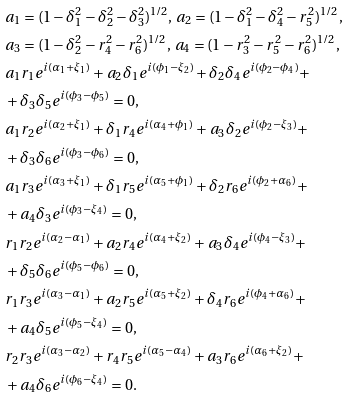<formula> <loc_0><loc_0><loc_500><loc_500>& a _ { 1 } = ( 1 - \delta ^ { 2 } _ { 1 } - \delta ^ { 2 } _ { 2 } - \delta ^ { 2 } _ { 3 } ) ^ { 1 / 2 } , \, a _ { 2 } = ( 1 - \delta ^ { 2 } _ { 1 } - \delta ^ { 2 } _ { 4 } - r ^ { 2 } _ { 5 } ) ^ { 1 / 2 } , \\ & a _ { 3 } = ( 1 - \delta ^ { 2 } _ { 2 } - r ^ { 2 } _ { 4 } - r ^ { 2 } _ { 6 } ) ^ { 1 / 2 } , \, a _ { 4 } = ( 1 - r ^ { 2 } _ { 3 } - r ^ { 2 } _ { 5 } - r ^ { 2 } _ { 6 } ) ^ { 1 / 2 } , \\ & a _ { 1 } r _ { 1 } e ^ { i ( \alpha _ { 1 } + \xi _ { 1 } ) } + a _ { 2 } \delta _ { 1 } e ^ { i ( \phi _ { 1 } - \xi _ { 2 } ) } + \delta _ { 2 } \delta _ { 4 } e ^ { i ( \phi _ { 2 } - \phi _ { 4 } ) } + \\ & + \delta _ { 3 } \delta _ { 5 } e ^ { i ( \phi _ { 3 } - \phi _ { 5 } ) } = 0 , \\ & a _ { 1 } r _ { 2 } e ^ { i ( \alpha _ { 2 } + \xi _ { 1 } ) } + \delta _ { 1 } r _ { 4 } e ^ { i ( \alpha _ { 4 } + \phi _ { 1 } ) } + a _ { 3 } \delta _ { 2 } e ^ { i ( \phi _ { 2 } - \xi _ { 3 } ) } + \\ & + \delta _ { 3 } \delta _ { 6 } e ^ { i ( \phi _ { 3 } - \phi _ { 6 } ) } = 0 , \\ & a _ { 1 } r _ { 3 } e ^ { i ( \alpha _ { 3 } + \xi _ { 1 } ) } + \delta _ { 1 } r _ { 5 } e ^ { i ( \alpha _ { 5 } + \phi _ { 1 } ) } + \delta _ { 2 } r _ { 6 } e ^ { i ( \phi _ { 2 } + \alpha _ { 6 } ) } + \\ & + a _ { 4 } \delta _ { 3 } e ^ { i ( \phi _ { 3 } - \xi _ { 4 } ) } = 0 , \\ & r _ { 1 } r _ { 2 } e ^ { i ( \alpha _ { 2 } - \alpha _ { 1 } ) } + a _ { 2 } r _ { 4 } e ^ { i ( \alpha _ { 4 } + \xi _ { 2 } ) } + a _ { 3 } \delta _ { 4 } e ^ { i ( \phi _ { 4 } - \xi _ { 3 } ) } + \\ & + \delta _ { 5 } \delta _ { 6 } e ^ { i ( \phi _ { 5 } - \phi _ { 6 } ) } = 0 , \\ & r _ { 1 } r _ { 3 } e ^ { i ( \alpha _ { 3 } - \alpha _ { 1 } ) } + a _ { 2 } r _ { 5 } e ^ { i ( \alpha _ { 5 } + \xi _ { 2 } ) } + \delta _ { 4 } r _ { 6 } e ^ { i ( \phi _ { 4 } + \alpha _ { 6 } ) } + \\ & + a _ { 4 } \delta _ { 5 } e ^ { i ( \phi _ { 5 } - \xi _ { 4 } ) } = 0 , \\ & r _ { 2 } r _ { 3 } e ^ { i ( \alpha _ { 3 } - \alpha _ { 2 } ) } + r _ { 4 } r _ { 5 } e ^ { i ( \alpha _ { 5 } - \alpha _ { 4 } ) } + a _ { 3 } r _ { 6 } e ^ { i ( \alpha _ { 6 } + \xi _ { 2 } ) } + \\ & + a _ { 4 } \delta _ { 6 } e ^ { i ( \phi _ { 6 } - \xi _ { 4 } ) } = 0 .</formula> 